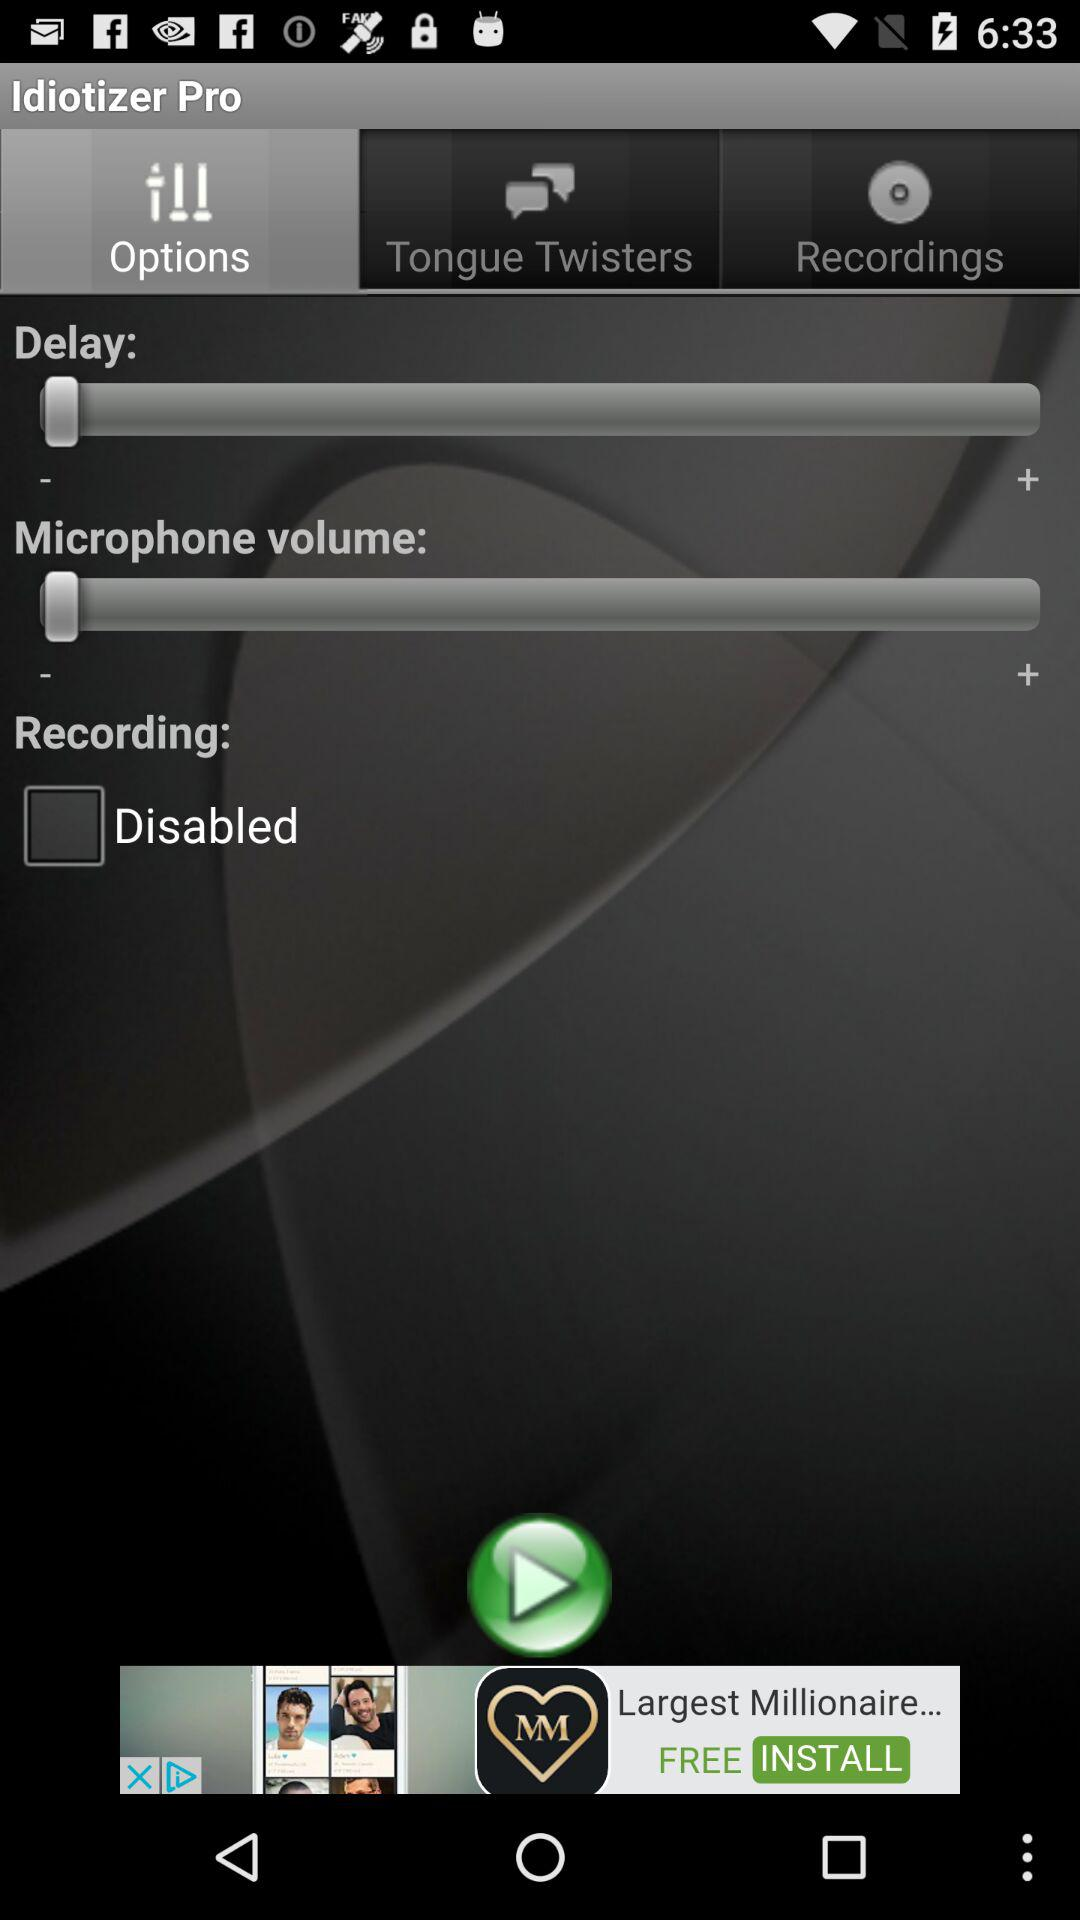What is the application name? The application name is "Idiotizer Pro". 